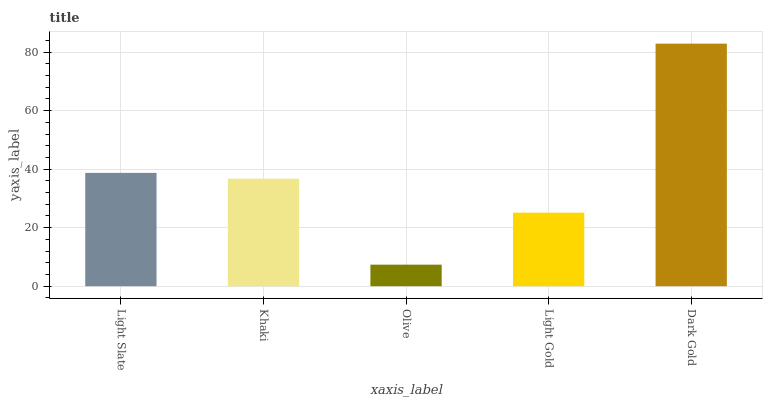Is Olive the minimum?
Answer yes or no. Yes. Is Dark Gold the maximum?
Answer yes or no. Yes. Is Khaki the minimum?
Answer yes or no. No. Is Khaki the maximum?
Answer yes or no. No. Is Light Slate greater than Khaki?
Answer yes or no. Yes. Is Khaki less than Light Slate?
Answer yes or no. Yes. Is Khaki greater than Light Slate?
Answer yes or no. No. Is Light Slate less than Khaki?
Answer yes or no. No. Is Khaki the high median?
Answer yes or no. Yes. Is Khaki the low median?
Answer yes or no. Yes. Is Light Gold the high median?
Answer yes or no. No. Is Light Slate the low median?
Answer yes or no. No. 